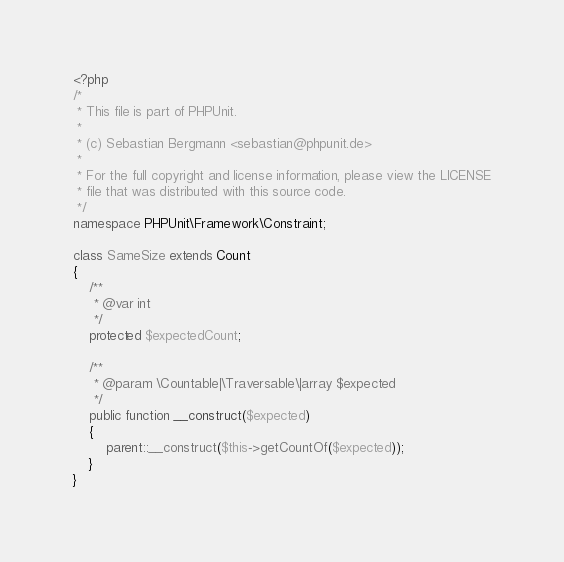Convert code to text. <code><loc_0><loc_0><loc_500><loc_500><_PHP_><?php
/*
 * This file is part of PHPUnit.
 *
 * (c) Sebastian Bergmann <sebastian@phpunit.de>
 *
 * For the full copyright and license information, please view the LICENSE
 * file that was distributed with this source code.
 */
namespace PHPUnit\Framework\Constraint;

class SameSize extends Count
{
    /**
     * @var int
     */
    protected $expectedCount;

    /**
     * @param \Countable|\Traversable\|array $expected
     */
    public function __construct($expected)
    {
        parent::__construct($this->getCountOf($expected));
    }
}
</code> 